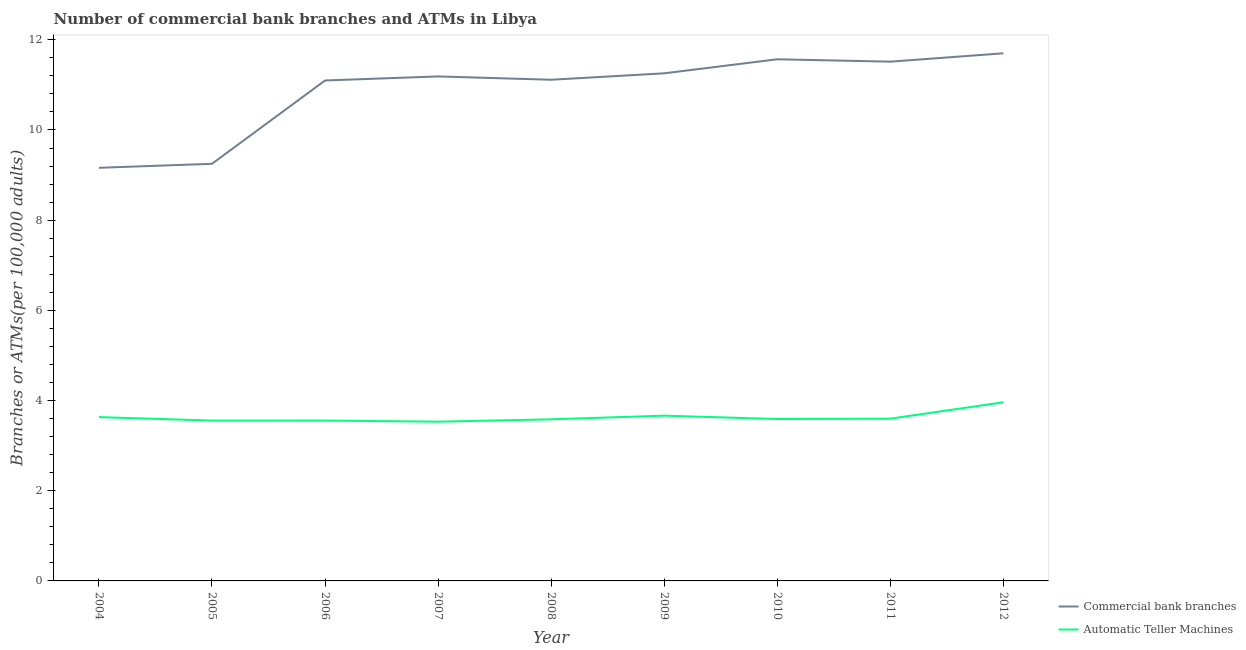How many different coloured lines are there?
Your answer should be compact. 2. Does the line corresponding to number of commercal bank branches intersect with the line corresponding to number of atms?
Your answer should be very brief. No. Is the number of lines equal to the number of legend labels?
Keep it short and to the point. Yes. What is the number of commercal bank branches in 2011?
Ensure brevity in your answer.  11.51. Across all years, what is the maximum number of commercal bank branches?
Your response must be concise. 11.7. Across all years, what is the minimum number of atms?
Keep it short and to the point. 3.53. In which year was the number of commercal bank branches maximum?
Ensure brevity in your answer.  2012. In which year was the number of commercal bank branches minimum?
Offer a very short reply. 2004. What is the total number of atms in the graph?
Keep it short and to the point. 32.67. What is the difference between the number of atms in 2005 and that in 2010?
Keep it short and to the point. -0.03. What is the difference between the number of commercal bank branches in 2011 and the number of atms in 2008?
Give a very brief answer. 7.93. What is the average number of atms per year?
Your answer should be compact. 3.63. In the year 2012, what is the difference between the number of commercal bank branches and number of atms?
Your answer should be compact. 7.74. What is the ratio of the number of atms in 2006 to that in 2007?
Your response must be concise. 1.01. Is the number of atms in 2005 less than that in 2007?
Your answer should be very brief. No. Is the difference between the number of atms in 2004 and 2011 greater than the difference between the number of commercal bank branches in 2004 and 2011?
Ensure brevity in your answer.  Yes. What is the difference between the highest and the second highest number of atms?
Keep it short and to the point. 0.3. What is the difference between the highest and the lowest number of atms?
Provide a succinct answer. 0.43. Does the number of commercal bank branches monotonically increase over the years?
Offer a very short reply. No. Is the number of commercal bank branches strictly less than the number of atms over the years?
Give a very brief answer. No. What is the difference between two consecutive major ticks on the Y-axis?
Your answer should be very brief. 2. Are the values on the major ticks of Y-axis written in scientific E-notation?
Ensure brevity in your answer.  No. Does the graph contain any zero values?
Ensure brevity in your answer.  No. Where does the legend appear in the graph?
Provide a short and direct response. Bottom right. How are the legend labels stacked?
Keep it short and to the point. Vertical. What is the title of the graph?
Ensure brevity in your answer.  Number of commercial bank branches and ATMs in Libya. Does "Research and Development" appear as one of the legend labels in the graph?
Keep it short and to the point. No. What is the label or title of the Y-axis?
Give a very brief answer. Branches or ATMs(per 100,0 adults). What is the Branches or ATMs(per 100,000 adults) in Commercial bank branches in 2004?
Your answer should be very brief. 9.16. What is the Branches or ATMs(per 100,000 adults) of Automatic Teller Machines in 2004?
Provide a short and direct response. 3.63. What is the Branches or ATMs(per 100,000 adults) in Commercial bank branches in 2005?
Keep it short and to the point. 9.25. What is the Branches or ATMs(per 100,000 adults) in Automatic Teller Machines in 2005?
Your response must be concise. 3.56. What is the Branches or ATMs(per 100,000 adults) in Commercial bank branches in 2006?
Give a very brief answer. 11.1. What is the Branches or ATMs(per 100,000 adults) in Automatic Teller Machines in 2006?
Offer a terse response. 3.56. What is the Branches or ATMs(per 100,000 adults) in Commercial bank branches in 2007?
Ensure brevity in your answer.  11.19. What is the Branches or ATMs(per 100,000 adults) of Automatic Teller Machines in 2007?
Your response must be concise. 3.53. What is the Branches or ATMs(per 100,000 adults) of Commercial bank branches in 2008?
Make the answer very short. 11.11. What is the Branches or ATMs(per 100,000 adults) in Automatic Teller Machines in 2008?
Provide a short and direct response. 3.58. What is the Branches or ATMs(per 100,000 adults) in Commercial bank branches in 2009?
Give a very brief answer. 11.26. What is the Branches or ATMs(per 100,000 adults) in Automatic Teller Machines in 2009?
Keep it short and to the point. 3.66. What is the Branches or ATMs(per 100,000 adults) in Commercial bank branches in 2010?
Your response must be concise. 11.57. What is the Branches or ATMs(per 100,000 adults) in Automatic Teller Machines in 2010?
Offer a terse response. 3.59. What is the Branches or ATMs(per 100,000 adults) of Commercial bank branches in 2011?
Keep it short and to the point. 11.51. What is the Branches or ATMs(per 100,000 adults) of Automatic Teller Machines in 2011?
Your response must be concise. 3.6. What is the Branches or ATMs(per 100,000 adults) in Commercial bank branches in 2012?
Give a very brief answer. 11.7. What is the Branches or ATMs(per 100,000 adults) of Automatic Teller Machines in 2012?
Your answer should be very brief. 3.96. Across all years, what is the maximum Branches or ATMs(per 100,000 adults) of Commercial bank branches?
Keep it short and to the point. 11.7. Across all years, what is the maximum Branches or ATMs(per 100,000 adults) in Automatic Teller Machines?
Offer a terse response. 3.96. Across all years, what is the minimum Branches or ATMs(per 100,000 adults) in Commercial bank branches?
Offer a very short reply. 9.16. Across all years, what is the minimum Branches or ATMs(per 100,000 adults) of Automatic Teller Machines?
Provide a short and direct response. 3.53. What is the total Branches or ATMs(per 100,000 adults) in Commercial bank branches in the graph?
Offer a very short reply. 97.85. What is the total Branches or ATMs(per 100,000 adults) in Automatic Teller Machines in the graph?
Provide a succinct answer. 32.67. What is the difference between the Branches or ATMs(per 100,000 adults) in Commercial bank branches in 2004 and that in 2005?
Your answer should be very brief. -0.09. What is the difference between the Branches or ATMs(per 100,000 adults) in Automatic Teller Machines in 2004 and that in 2005?
Provide a short and direct response. 0.08. What is the difference between the Branches or ATMs(per 100,000 adults) in Commercial bank branches in 2004 and that in 2006?
Your response must be concise. -1.94. What is the difference between the Branches or ATMs(per 100,000 adults) in Automatic Teller Machines in 2004 and that in 2006?
Your answer should be very brief. 0.08. What is the difference between the Branches or ATMs(per 100,000 adults) of Commercial bank branches in 2004 and that in 2007?
Keep it short and to the point. -2.03. What is the difference between the Branches or ATMs(per 100,000 adults) in Automatic Teller Machines in 2004 and that in 2007?
Provide a short and direct response. 0.1. What is the difference between the Branches or ATMs(per 100,000 adults) in Commercial bank branches in 2004 and that in 2008?
Your answer should be compact. -1.95. What is the difference between the Branches or ATMs(per 100,000 adults) in Automatic Teller Machines in 2004 and that in 2008?
Offer a terse response. 0.05. What is the difference between the Branches or ATMs(per 100,000 adults) of Commercial bank branches in 2004 and that in 2009?
Provide a succinct answer. -2.1. What is the difference between the Branches or ATMs(per 100,000 adults) of Automatic Teller Machines in 2004 and that in 2009?
Your answer should be very brief. -0.03. What is the difference between the Branches or ATMs(per 100,000 adults) of Commercial bank branches in 2004 and that in 2010?
Make the answer very short. -2.41. What is the difference between the Branches or ATMs(per 100,000 adults) in Automatic Teller Machines in 2004 and that in 2010?
Your answer should be compact. 0.04. What is the difference between the Branches or ATMs(per 100,000 adults) in Commercial bank branches in 2004 and that in 2011?
Give a very brief answer. -2.35. What is the difference between the Branches or ATMs(per 100,000 adults) in Automatic Teller Machines in 2004 and that in 2011?
Provide a succinct answer. 0.03. What is the difference between the Branches or ATMs(per 100,000 adults) in Commercial bank branches in 2004 and that in 2012?
Your response must be concise. -2.54. What is the difference between the Branches or ATMs(per 100,000 adults) in Automatic Teller Machines in 2004 and that in 2012?
Keep it short and to the point. -0.33. What is the difference between the Branches or ATMs(per 100,000 adults) in Commercial bank branches in 2005 and that in 2006?
Provide a succinct answer. -1.85. What is the difference between the Branches or ATMs(per 100,000 adults) in Automatic Teller Machines in 2005 and that in 2006?
Ensure brevity in your answer.  -0. What is the difference between the Branches or ATMs(per 100,000 adults) in Commercial bank branches in 2005 and that in 2007?
Ensure brevity in your answer.  -1.94. What is the difference between the Branches or ATMs(per 100,000 adults) in Automatic Teller Machines in 2005 and that in 2007?
Your answer should be very brief. 0.02. What is the difference between the Branches or ATMs(per 100,000 adults) in Commercial bank branches in 2005 and that in 2008?
Provide a short and direct response. -1.86. What is the difference between the Branches or ATMs(per 100,000 adults) in Automatic Teller Machines in 2005 and that in 2008?
Your answer should be very brief. -0.03. What is the difference between the Branches or ATMs(per 100,000 adults) in Commercial bank branches in 2005 and that in 2009?
Offer a very short reply. -2.01. What is the difference between the Branches or ATMs(per 100,000 adults) in Automatic Teller Machines in 2005 and that in 2009?
Your response must be concise. -0.11. What is the difference between the Branches or ATMs(per 100,000 adults) of Commercial bank branches in 2005 and that in 2010?
Your answer should be very brief. -2.32. What is the difference between the Branches or ATMs(per 100,000 adults) of Automatic Teller Machines in 2005 and that in 2010?
Offer a very short reply. -0.03. What is the difference between the Branches or ATMs(per 100,000 adults) in Commercial bank branches in 2005 and that in 2011?
Provide a short and direct response. -2.26. What is the difference between the Branches or ATMs(per 100,000 adults) of Automatic Teller Machines in 2005 and that in 2011?
Provide a succinct answer. -0.04. What is the difference between the Branches or ATMs(per 100,000 adults) in Commercial bank branches in 2005 and that in 2012?
Ensure brevity in your answer.  -2.45. What is the difference between the Branches or ATMs(per 100,000 adults) in Automatic Teller Machines in 2005 and that in 2012?
Provide a short and direct response. -0.41. What is the difference between the Branches or ATMs(per 100,000 adults) in Commercial bank branches in 2006 and that in 2007?
Offer a very short reply. -0.09. What is the difference between the Branches or ATMs(per 100,000 adults) in Automatic Teller Machines in 2006 and that in 2007?
Give a very brief answer. 0.02. What is the difference between the Branches or ATMs(per 100,000 adults) in Commercial bank branches in 2006 and that in 2008?
Keep it short and to the point. -0.02. What is the difference between the Branches or ATMs(per 100,000 adults) in Automatic Teller Machines in 2006 and that in 2008?
Your response must be concise. -0.03. What is the difference between the Branches or ATMs(per 100,000 adults) of Commercial bank branches in 2006 and that in 2009?
Offer a terse response. -0.16. What is the difference between the Branches or ATMs(per 100,000 adults) in Automatic Teller Machines in 2006 and that in 2009?
Make the answer very short. -0.11. What is the difference between the Branches or ATMs(per 100,000 adults) of Commercial bank branches in 2006 and that in 2010?
Make the answer very short. -0.47. What is the difference between the Branches or ATMs(per 100,000 adults) in Automatic Teller Machines in 2006 and that in 2010?
Offer a very short reply. -0.03. What is the difference between the Branches or ATMs(per 100,000 adults) in Commercial bank branches in 2006 and that in 2011?
Make the answer very short. -0.42. What is the difference between the Branches or ATMs(per 100,000 adults) of Automatic Teller Machines in 2006 and that in 2011?
Provide a short and direct response. -0.04. What is the difference between the Branches or ATMs(per 100,000 adults) in Commercial bank branches in 2006 and that in 2012?
Offer a terse response. -0.6. What is the difference between the Branches or ATMs(per 100,000 adults) of Automatic Teller Machines in 2006 and that in 2012?
Keep it short and to the point. -0.41. What is the difference between the Branches or ATMs(per 100,000 adults) in Commercial bank branches in 2007 and that in 2008?
Make the answer very short. 0.07. What is the difference between the Branches or ATMs(per 100,000 adults) of Automatic Teller Machines in 2007 and that in 2008?
Offer a very short reply. -0.05. What is the difference between the Branches or ATMs(per 100,000 adults) of Commercial bank branches in 2007 and that in 2009?
Your answer should be very brief. -0.07. What is the difference between the Branches or ATMs(per 100,000 adults) in Automatic Teller Machines in 2007 and that in 2009?
Make the answer very short. -0.13. What is the difference between the Branches or ATMs(per 100,000 adults) of Commercial bank branches in 2007 and that in 2010?
Provide a short and direct response. -0.38. What is the difference between the Branches or ATMs(per 100,000 adults) of Automatic Teller Machines in 2007 and that in 2010?
Provide a succinct answer. -0.06. What is the difference between the Branches or ATMs(per 100,000 adults) in Commercial bank branches in 2007 and that in 2011?
Keep it short and to the point. -0.33. What is the difference between the Branches or ATMs(per 100,000 adults) in Automatic Teller Machines in 2007 and that in 2011?
Make the answer very short. -0.07. What is the difference between the Branches or ATMs(per 100,000 adults) of Commercial bank branches in 2007 and that in 2012?
Your answer should be very brief. -0.51. What is the difference between the Branches or ATMs(per 100,000 adults) in Automatic Teller Machines in 2007 and that in 2012?
Provide a succinct answer. -0.43. What is the difference between the Branches or ATMs(per 100,000 adults) in Commercial bank branches in 2008 and that in 2009?
Keep it short and to the point. -0.14. What is the difference between the Branches or ATMs(per 100,000 adults) in Automatic Teller Machines in 2008 and that in 2009?
Provide a short and direct response. -0.08. What is the difference between the Branches or ATMs(per 100,000 adults) of Commercial bank branches in 2008 and that in 2010?
Make the answer very short. -0.45. What is the difference between the Branches or ATMs(per 100,000 adults) in Automatic Teller Machines in 2008 and that in 2010?
Offer a terse response. -0.01. What is the difference between the Branches or ATMs(per 100,000 adults) in Commercial bank branches in 2008 and that in 2011?
Make the answer very short. -0.4. What is the difference between the Branches or ATMs(per 100,000 adults) in Automatic Teller Machines in 2008 and that in 2011?
Give a very brief answer. -0.01. What is the difference between the Branches or ATMs(per 100,000 adults) in Commercial bank branches in 2008 and that in 2012?
Provide a succinct answer. -0.59. What is the difference between the Branches or ATMs(per 100,000 adults) of Automatic Teller Machines in 2008 and that in 2012?
Your answer should be compact. -0.38. What is the difference between the Branches or ATMs(per 100,000 adults) of Commercial bank branches in 2009 and that in 2010?
Offer a very short reply. -0.31. What is the difference between the Branches or ATMs(per 100,000 adults) of Automatic Teller Machines in 2009 and that in 2010?
Provide a succinct answer. 0.07. What is the difference between the Branches or ATMs(per 100,000 adults) of Commercial bank branches in 2009 and that in 2011?
Provide a short and direct response. -0.26. What is the difference between the Branches or ATMs(per 100,000 adults) of Automatic Teller Machines in 2009 and that in 2011?
Make the answer very short. 0.07. What is the difference between the Branches or ATMs(per 100,000 adults) in Commercial bank branches in 2009 and that in 2012?
Give a very brief answer. -0.44. What is the difference between the Branches or ATMs(per 100,000 adults) of Automatic Teller Machines in 2009 and that in 2012?
Your response must be concise. -0.3. What is the difference between the Branches or ATMs(per 100,000 adults) of Commercial bank branches in 2010 and that in 2011?
Your answer should be compact. 0.05. What is the difference between the Branches or ATMs(per 100,000 adults) in Automatic Teller Machines in 2010 and that in 2011?
Keep it short and to the point. -0.01. What is the difference between the Branches or ATMs(per 100,000 adults) of Commercial bank branches in 2010 and that in 2012?
Provide a succinct answer. -0.13. What is the difference between the Branches or ATMs(per 100,000 adults) in Automatic Teller Machines in 2010 and that in 2012?
Your response must be concise. -0.37. What is the difference between the Branches or ATMs(per 100,000 adults) in Commercial bank branches in 2011 and that in 2012?
Provide a succinct answer. -0.19. What is the difference between the Branches or ATMs(per 100,000 adults) of Automatic Teller Machines in 2011 and that in 2012?
Offer a very short reply. -0.36. What is the difference between the Branches or ATMs(per 100,000 adults) of Commercial bank branches in 2004 and the Branches or ATMs(per 100,000 adults) of Automatic Teller Machines in 2005?
Your answer should be compact. 5.61. What is the difference between the Branches or ATMs(per 100,000 adults) of Commercial bank branches in 2004 and the Branches or ATMs(per 100,000 adults) of Automatic Teller Machines in 2006?
Provide a short and direct response. 5.6. What is the difference between the Branches or ATMs(per 100,000 adults) in Commercial bank branches in 2004 and the Branches or ATMs(per 100,000 adults) in Automatic Teller Machines in 2007?
Ensure brevity in your answer.  5.63. What is the difference between the Branches or ATMs(per 100,000 adults) of Commercial bank branches in 2004 and the Branches or ATMs(per 100,000 adults) of Automatic Teller Machines in 2008?
Provide a succinct answer. 5.58. What is the difference between the Branches or ATMs(per 100,000 adults) of Commercial bank branches in 2004 and the Branches or ATMs(per 100,000 adults) of Automatic Teller Machines in 2009?
Offer a terse response. 5.5. What is the difference between the Branches or ATMs(per 100,000 adults) in Commercial bank branches in 2004 and the Branches or ATMs(per 100,000 adults) in Automatic Teller Machines in 2010?
Provide a succinct answer. 5.57. What is the difference between the Branches or ATMs(per 100,000 adults) in Commercial bank branches in 2004 and the Branches or ATMs(per 100,000 adults) in Automatic Teller Machines in 2011?
Your answer should be compact. 5.56. What is the difference between the Branches or ATMs(per 100,000 adults) of Commercial bank branches in 2004 and the Branches or ATMs(per 100,000 adults) of Automatic Teller Machines in 2012?
Your response must be concise. 5.2. What is the difference between the Branches or ATMs(per 100,000 adults) of Commercial bank branches in 2005 and the Branches or ATMs(per 100,000 adults) of Automatic Teller Machines in 2006?
Your response must be concise. 5.69. What is the difference between the Branches or ATMs(per 100,000 adults) in Commercial bank branches in 2005 and the Branches or ATMs(per 100,000 adults) in Automatic Teller Machines in 2007?
Provide a short and direct response. 5.72. What is the difference between the Branches or ATMs(per 100,000 adults) in Commercial bank branches in 2005 and the Branches or ATMs(per 100,000 adults) in Automatic Teller Machines in 2008?
Provide a short and direct response. 5.67. What is the difference between the Branches or ATMs(per 100,000 adults) of Commercial bank branches in 2005 and the Branches or ATMs(per 100,000 adults) of Automatic Teller Machines in 2009?
Provide a short and direct response. 5.58. What is the difference between the Branches or ATMs(per 100,000 adults) of Commercial bank branches in 2005 and the Branches or ATMs(per 100,000 adults) of Automatic Teller Machines in 2010?
Offer a very short reply. 5.66. What is the difference between the Branches or ATMs(per 100,000 adults) of Commercial bank branches in 2005 and the Branches or ATMs(per 100,000 adults) of Automatic Teller Machines in 2011?
Your response must be concise. 5.65. What is the difference between the Branches or ATMs(per 100,000 adults) of Commercial bank branches in 2005 and the Branches or ATMs(per 100,000 adults) of Automatic Teller Machines in 2012?
Your answer should be compact. 5.29. What is the difference between the Branches or ATMs(per 100,000 adults) in Commercial bank branches in 2006 and the Branches or ATMs(per 100,000 adults) in Automatic Teller Machines in 2007?
Offer a very short reply. 7.57. What is the difference between the Branches or ATMs(per 100,000 adults) of Commercial bank branches in 2006 and the Branches or ATMs(per 100,000 adults) of Automatic Teller Machines in 2008?
Offer a terse response. 7.51. What is the difference between the Branches or ATMs(per 100,000 adults) in Commercial bank branches in 2006 and the Branches or ATMs(per 100,000 adults) in Automatic Teller Machines in 2009?
Keep it short and to the point. 7.43. What is the difference between the Branches or ATMs(per 100,000 adults) of Commercial bank branches in 2006 and the Branches or ATMs(per 100,000 adults) of Automatic Teller Machines in 2010?
Give a very brief answer. 7.51. What is the difference between the Branches or ATMs(per 100,000 adults) in Commercial bank branches in 2006 and the Branches or ATMs(per 100,000 adults) in Automatic Teller Machines in 2011?
Give a very brief answer. 7.5. What is the difference between the Branches or ATMs(per 100,000 adults) in Commercial bank branches in 2006 and the Branches or ATMs(per 100,000 adults) in Automatic Teller Machines in 2012?
Provide a succinct answer. 7.14. What is the difference between the Branches or ATMs(per 100,000 adults) of Commercial bank branches in 2007 and the Branches or ATMs(per 100,000 adults) of Automatic Teller Machines in 2008?
Your response must be concise. 7.6. What is the difference between the Branches or ATMs(per 100,000 adults) of Commercial bank branches in 2007 and the Branches or ATMs(per 100,000 adults) of Automatic Teller Machines in 2009?
Your answer should be compact. 7.52. What is the difference between the Branches or ATMs(per 100,000 adults) of Commercial bank branches in 2007 and the Branches or ATMs(per 100,000 adults) of Automatic Teller Machines in 2010?
Provide a succinct answer. 7.6. What is the difference between the Branches or ATMs(per 100,000 adults) in Commercial bank branches in 2007 and the Branches or ATMs(per 100,000 adults) in Automatic Teller Machines in 2011?
Make the answer very short. 7.59. What is the difference between the Branches or ATMs(per 100,000 adults) in Commercial bank branches in 2007 and the Branches or ATMs(per 100,000 adults) in Automatic Teller Machines in 2012?
Provide a succinct answer. 7.23. What is the difference between the Branches or ATMs(per 100,000 adults) of Commercial bank branches in 2008 and the Branches or ATMs(per 100,000 adults) of Automatic Teller Machines in 2009?
Provide a succinct answer. 7.45. What is the difference between the Branches or ATMs(per 100,000 adults) in Commercial bank branches in 2008 and the Branches or ATMs(per 100,000 adults) in Automatic Teller Machines in 2010?
Keep it short and to the point. 7.52. What is the difference between the Branches or ATMs(per 100,000 adults) in Commercial bank branches in 2008 and the Branches or ATMs(per 100,000 adults) in Automatic Teller Machines in 2011?
Provide a succinct answer. 7.52. What is the difference between the Branches or ATMs(per 100,000 adults) of Commercial bank branches in 2008 and the Branches or ATMs(per 100,000 adults) of Automatic Teller Machines in 2012?
Offer a very short reply. 7.15. What is the difference between the Branches or ATMs(per 100,000 adults) in Commercial bank branches in 2009 and the Branches or ATMs(per 100,000 adults) in Automatic Teller Machines in 2010?
Make the answer very short. 7.67. What is the difference between the Branches or ATMs(per 100,000 adults) in Commercial bank branches in 2009 and the Branches or ATMs(per 100,000 adults) in Automatic Teller Machines in 2011?
Make the answer very short. 7.66. What is the difference between the Branches or ATMs(per 100,000 adults) in Commercial bank branches in 2009 and the Branches or ATMs(per 100,000 adults) in Automatic Teller Machines in 2012?
Your answer should be very brief. 7.29. What is the difference between the Branches or ATMs(per 100,000 adults) of Commercial bank branches in 2010 and the Branches or ATMs(per 100,000 adults) of Automatic Teller Machines in 2011?
Give a very brief answer. 7.97. What is the difference between the Branches or ATMs(per 100,000 adults) of Commercial bank branches in 2010 and the Branches or ATMs(per 100,000 adults) of Automatic Teller Machines in 2012?
Offer a very short reply. 7.61. What is the difference between the Branches or ATMs(per 100,000 adults) in Commercial bank branches in 2011 and the Branches or ATMs(per 100,000 adults) in Automatic Teller Machines in 2012?
Offer a terse response. 7.55. What is the average Branches or ATMs(per 100,000 adults) of Commercial bank branches per year?
Your answer should be very brief. 10.87. What is the average Branches or ATMs(per 100,000 adults) in Automatic Teller Machines per year?
Ensure brevity in your answer.  3.63. In the year 2004, what is the difference between the Branches or ATMs(per 100,000 adults) in Commercial bank branches and Branches or ATMs(per 100,000 adults) in Automatic Teller Machines?
Ensure brevity in your answer.  5.53. In the year 2005, what is the difference between the Branches or ATMs(per 100,000 adults) of Commercial bank branches and Branches or ATMs(per 100,000 adults) of Automatic Teller Machines?
Keep it short and to the point. 5.69. In the year 2006, what is the difference between the Branches or ATMs(per 100,000 adults) of Commercial bank branches and Branches or ATMs(per 100,000 adults) of Automatic Teller Machines?
Ensure brevity in your answer.  7.54. In the year 2007, what is the difference between the Branches or ATMs(per 100,000 adults) of Commercial bank branches and Branches or ATMs(per 100,000 adults) of Automatic Teller Machines?
Provide a short and direct response. 7.66. In the year 2008, what is the difference between the Branches or ATMs(per 100,000 adults) of Commercial bank branches and Branches or ATMs(per 100,000 adults) of Automatic Teller Machines?
Your answer should be very brief. 7.53. In the year 2009, what is the difference between the Branches or ATMs(per 100,000 adults) in Commercial bank branches and Branches or ATMs(per 100,000 adults) in Automatic Teller Machines?
Offer a terse response. 7.59. In the year 2010, what is the difference between the Branches or ATMs(per 100,000 adults) of Commercial bank branches and Branches or ATMs(per 100,000 adults) of Automatic Teller Machines?
Ensure brevity in your answer.  7.98. In the year 2011, what is the difference between the Branches or ATMs(per 100,000 adults) of Commercial bank branches and Branches or ATMs(per 100,000 adults) of Automatic Teller Machines?
Offer a terse response. 7.92. In the year 2012, what is the difference between the Branches or ATMs(per 100,000 adults) in Commercial bank branches and Branches or ATMs(per 100,000 adults) in Automatic Teller Machines?
Provide a succinct answer. 7.74. What is the ratio of the Branches or ATMs(per 100,000 adults) of Automatic Teller Machines in 2004 to that in 2005?
Offer a very short reply. 1.02. What is the ratio of the Branches or ATMs(per 100,000 adults) of Commercial bank branches in 2004 to that in 2006?
Your answer should be very brief. 0.83. What is the ratio of the Branches or ATMs(per 100,000 adults) in Automatic Teller Machines in 2004 to that in 2006?
Make the answer very short. 1.02. What is the ratio of the Branches or ATMs(per 100,000 adults) of Commercial bank branches in 2004 to that in 2007?
Make the answer very short. 0.82. What is the ratio of the Branches or ATMs(per 100,000 adults) of Automatic Teller Machines in 2004 to that in 2007?
Your response must be concise. 1.03. What is the ratio of the Branches or ATMs(per 100,000 adults) of Commercial bank branches in 2004 to that in 2008?
Ensure brevity in your answer.  0.82. What is the ratio of the Branches or ATMs(per 100,000 adults) in Automatic Teller Machines in 2004 to that in 2008?
Provide a succinct answer. 1.01. What is the ratio of the Branches or ATMs(per 100,000 adults) in Commercial bank branches in 2004 to that in 2009?
Make the answer very short. 0.81. What is the ratio of the Branches or ATMs(per 100,000 adults) of Automatic Teller Machines in 2004 to that in 2009?
Your answer should be compact. 0.99. What is the ratio of the Branches or ATMs(per 100,000 adults) of Commercial bank branches in 2004 to that in 2010?
Your answer should be very brief. 0.79. What is the ratio of the Branches or ATMs(per 100,000 adults) in Automatic Teller Machines in 2004 to that in 2010?
Give a very brief answer. 1.01. What is the ratio of the Branches or ATMs(per 100,000 adults) in Commercial bank branches in 2004 to that in 2011?
Keep it short and to the point. 0.8. What is the ratio of the Branches or ATMs(per 100,000 adults) in Automatic Teller Machines in 2004 to that in 2011?
Keep it short and to the point. 1.01. What is the ratio of the Branches or ATMs(per 100,000 adults) of Commercial bank branches in 2004 to that in 2012?
Offer a terse response. 0.78. What is the ratio of the Branches or ATMs(per 100,000 adults) in Automatic Teller Machines in 2004 to that in 2012?
Offer a terse response. 0.92. What is the ratio of the Branches or ATMs(per 100,000 adults) of Commercial bank branches in 2005 to that in 2006?
Your answer should be compact. 0.83. What is the ratio of the Branches or ATMs(per 100,000 adults) of Commercial bank branches in 2005 to that in 2007?
Your answer should be very brief. 0.83. What is the ratio of the Branches or ATMs(per 100,000 adults) in Automatic Teller Machines in 2005 to that in 2007?
Offer a very short reply. 1.01. What is the ratio of the Branches or ATMs(per 100,000 adults) of Commercial bank branches in 2005 to that in 2008?
Keep it short and to the point. 0.83. What is the ratio of the Branches or ATMs(per 100,000 adults) in Automatic Teller Machines in 2005 to that in 2008?
Ensure brevity in your answer.  0.99. What is the ratio of the Branches or ATMs(per 100,000 adults) in Commercial bank branches in 2005 to that in 2009?
Make the answer very short. 0.82. What is the ratio of the Branches or ATMs(per 100,000 adults) in Automatic Teller Machines in 2005 to that in 2009?
Give a very brief answer. 0.97. What is the ratio of the Branches or ATMs(per 100,000 adults) of Commercial bank branches in 2005 to that in 2010?
Offer a terse response. 0.8. What is the ratio of the Branches or ATMs(per 100,000 adults) in Commercial bank branches in 2005 to that in 2011?
Ensure brevity in your answer.  0.8. What is the ratio of the Branches or ATMs(per 100,000 adults) in Automatic Teller Machines in 2005 to that in 2011?
Give a very brief answer. 0.99. What is the ratio of the Branches or ATMs(per 100,000 adults) of Commercial bank branches in 2005 to that in 2012?
Keep it short and to the point. 0.79. What is the ratio of the Branches or ATMs(per 100,000 adults) of Automatic Teller Machines in 2005 to that in 2012?
Offer a very short reply. 0.9. What is the ratio of the Branches or ATMs(per 100,000 adults) of Commercial bank branches in 2006 to that in 2007?
Your answer should be compact. 0.99. What is the ratio of the Branches or ATMs(per 100,000 adults) of Automatic Teller Machines in 2006 to that in 2008?
Give a very brief answer. 0.99. What is the ratio of the Branches or ATMs(per 100,000 adults) of Commercial bank branches in 2006 to that in 2009?
Ensure brevity in your answer.  0.99. What is the ratio of the Branches or ATMs(per 100,000 adults) in Automatic Teller Machines in 2006 to that in 2009?
Ensure brevity in your answer.  0.97. What is the ratio of the Branches or ATMs(per 100,000 adults) in Commercial bank branches in 2006 to that in 2010?
Keep it short and to the point. 0.96. What is the ratio of the Branches or ATMs(per 100,000 adults) in Automatic Teller Machines in 2006 to that in 2010?
Your answer should be very brief. 0.99. What is the ratio of the Branches or ATMs(per 100,000 adults) in Commercial bank branches in 2006 to that in 2011?
Offer a terse response. 0.96. What is the ratio of the Branches or ATMs(per 100,000 adults) in Automatic Teller Machines in 2006 to that in 2011?
Your response must be concise. 0.99. What is the ratio of the Branches or ATMs(per 100,000 adults) in Commercial bank branches in 2006 to that in 2012?
Offer a very short reply. 0.95. What is the ratio of the Branches or ATMs(per 100,000 adults) in Automatic Teller Machines in 2006 to that in 2012?
Provide a short and direct response. 0.9. What is the ratio of the Branches or ATMs(per 100,000 adults) of Commercial bank branches in 2007 to that in 2008?
Your response must be concise. 1.01. What is the ratio of the Branches or ATMs(per 100,000 adults) in Automatic Teller Machines in 2007 to that in 2008?
Your answer should be compact. 0.99. What is the ratio of the Branches or ATMs(per 100,000 adults) in Automatic Teller Machines in 2007 to that in 2009?
Your answer should be compact. 0.96. What is the ratio of the Branches or ATMs(per 100,000 adults) in Commercial bank branches in 2007 to that in 2010?
Offer a very short reply. 0.97. What is the ratio of the Branches or ATMs(per 100,000 adults) in Automatic Teller Machines in 2007 to that in 2010?
Make the answer very short. 0.98. What is the ratio of the Branches or ATMs(per 100,000 adults) in Commercial bank branches in 2007 to that in 2011?
Your answer should be compact. 0.97. What is the ratio of the Branches or ATMs(per 100,000 adults) of Automatic Teller Machines in 2007 to that in 2011?
Give a very brief answer. 0.98. What is the ratio of the Branches or ATMs(per 100,000 adults) in Commercial bank branches in 2007 to that in 2012?
Give a very brief answer. 0.96. What is the ratio of the Branches or ATMs(per 100,000 adults) in Automatic Teller Machines in 2007 to that in 2012?
Provide a succinct answer. 0.89. What is the ratio of the Branches or ATMs(per 100,000 adults) of Commercial bank branches in 2008 to that in 2009?
Make the answer very short. 0.99. What is the ratio of the Branches or ATMs(per 100,000 adults) of Automatic Teller Machines in 2008 to that in 2009?
Provide a succinct answer. 0.98. What is the ratio of the Branches or ATMs(per 100,000 adults) of Commercial bank branches in 2008 to that in 2010?
Your response must be concise. 0.96. What is the ratio of the Branches or ATMs(per 100,000 adults) of Commercial bank branches in 2008 to that in 2011?
Make the answer very short. 0.97. What is the ratio of the Branches or ATMs(per 100,000 adults) in Automatic Teller Machines in 2008 to that in 2011?
Offer a terse response. 1. What is the ratio of the Branches or ATMs(per 100,000 adults) of Commercial bank branches in 2008 to that in 2012?
Offer a very short reply. 0.95. What is the ratio of the Branches or ATMs(per 100,000 adults) in Automatic Teller Machines in 2008 to that in 2012?
Offer a terse response. 0.9. What is the ratio of the Branches or ATMs(per 100,000 adults) of Commercial bank branches in 2009 to that in 2010?
Your response must be concise. 0.97. What is the ratio of the Branches or ATMs(per 100,000 adults) of Automatic Teller Machines in 2009 to that in 2010?
Provide a short and direct response. 1.02. What is the ratio of the Branches or ATMs(per 100,000 adults) of Commercial bank branches in 2009 to that in 2011?
Provide a short and direct response. 0.98. What is the ratio of the Branches or ATMs(per 100,000 adults) in Automatic Teller Machines in 2009 to that in 2011?
Provide a short and direct response. 1.02. What is the ratio of the Branches or ATMs(per 100,000 adults) of Commercial bank branches in 2009 to that in 2012?
Your response must be concise. 0.96. What is the ratio of the Branches or ATMs(per 100,000 adults) in Automatic Teller Machines in 2009 to that in 2012?
Provide a succinct answer. 0.93. What is the ratio of the Branches or ATMs(per 100,000 adults) in Commercial bank branches in 2010 to that in 2012?
Provide a short and direct response. 0.99. What is the ratio of the Branches or ATMs(per 100,000 adults) in Automatic Teller Machines in 2010 to that in 2012?
Your answer should be very brief. 0.91. What is the ratio of the Branches or ATMs(per 100,000 adults) of Commercial bank branches in 2011 to that in 2012?
Give a very brief answer. 0.98. What is the ratio of the Branches or ATMs(per 100,000 adults) of Automatic Teller Machines in 2011 to that in 2012?
Offer a terse response. 0.91. What is the difference between the highest and the second highest Branches or ATMs(per 100,000 adults) in Commercial bank branches?
Offer a very short reply. 0.13. What is the difference between the highest and the second highest Branches or ATMs(per 100,000 adults) of Automatic Teller Machines?
Keep it short and to the point. 0.3. What is the difference between the highest and the lowest Branches or ATMs(per 100,000 adults) in Commercial bank branches?
Make the answer very short. 2.54. What is the difference between the highest and the lowest Branches or ATMs(per 100,000 adults) in Automatic Teller Machines?
Your answer should be compact. 0.43. 